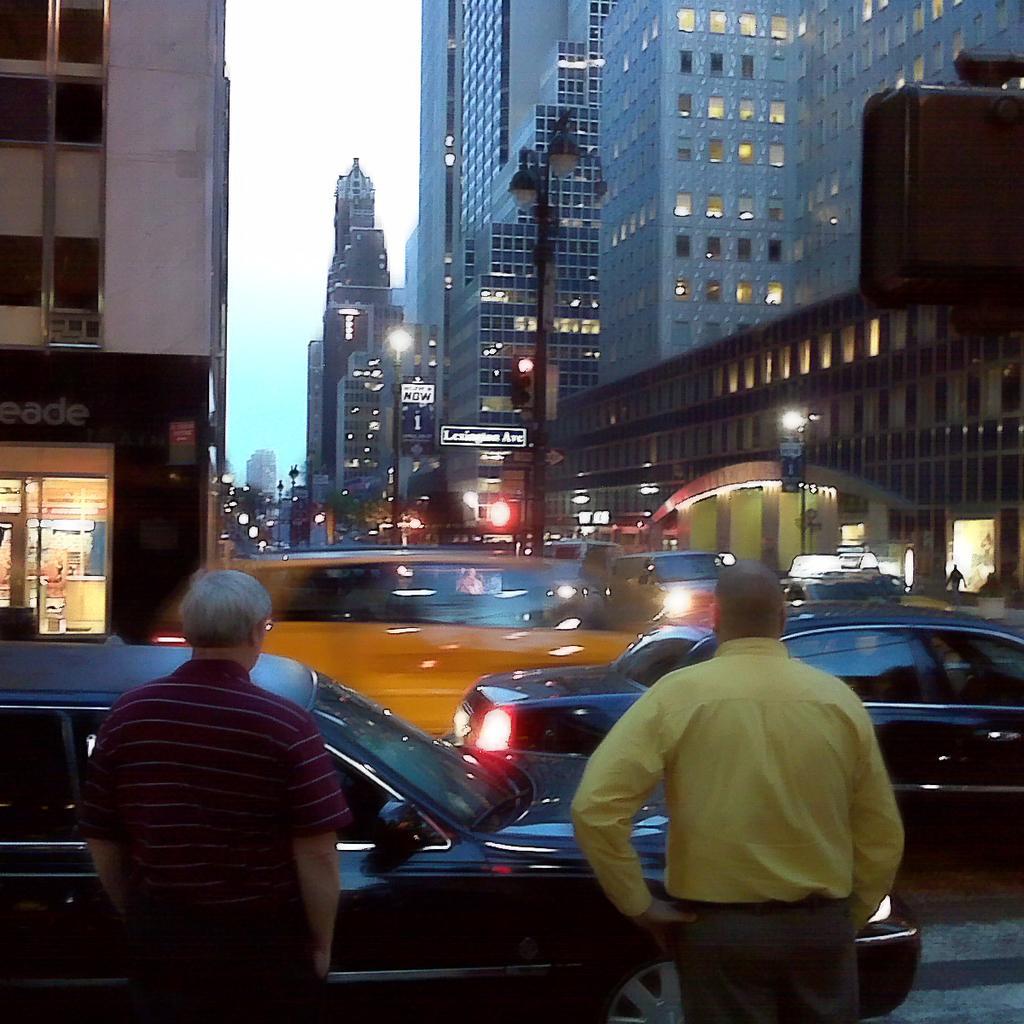Please provide a concise description of this image. In this image, we can see two people are standing. Here there are so many vehicles on the road. Background we can see buildings with walls and windows, poles, sign boards, hoarding, trees and sky. 